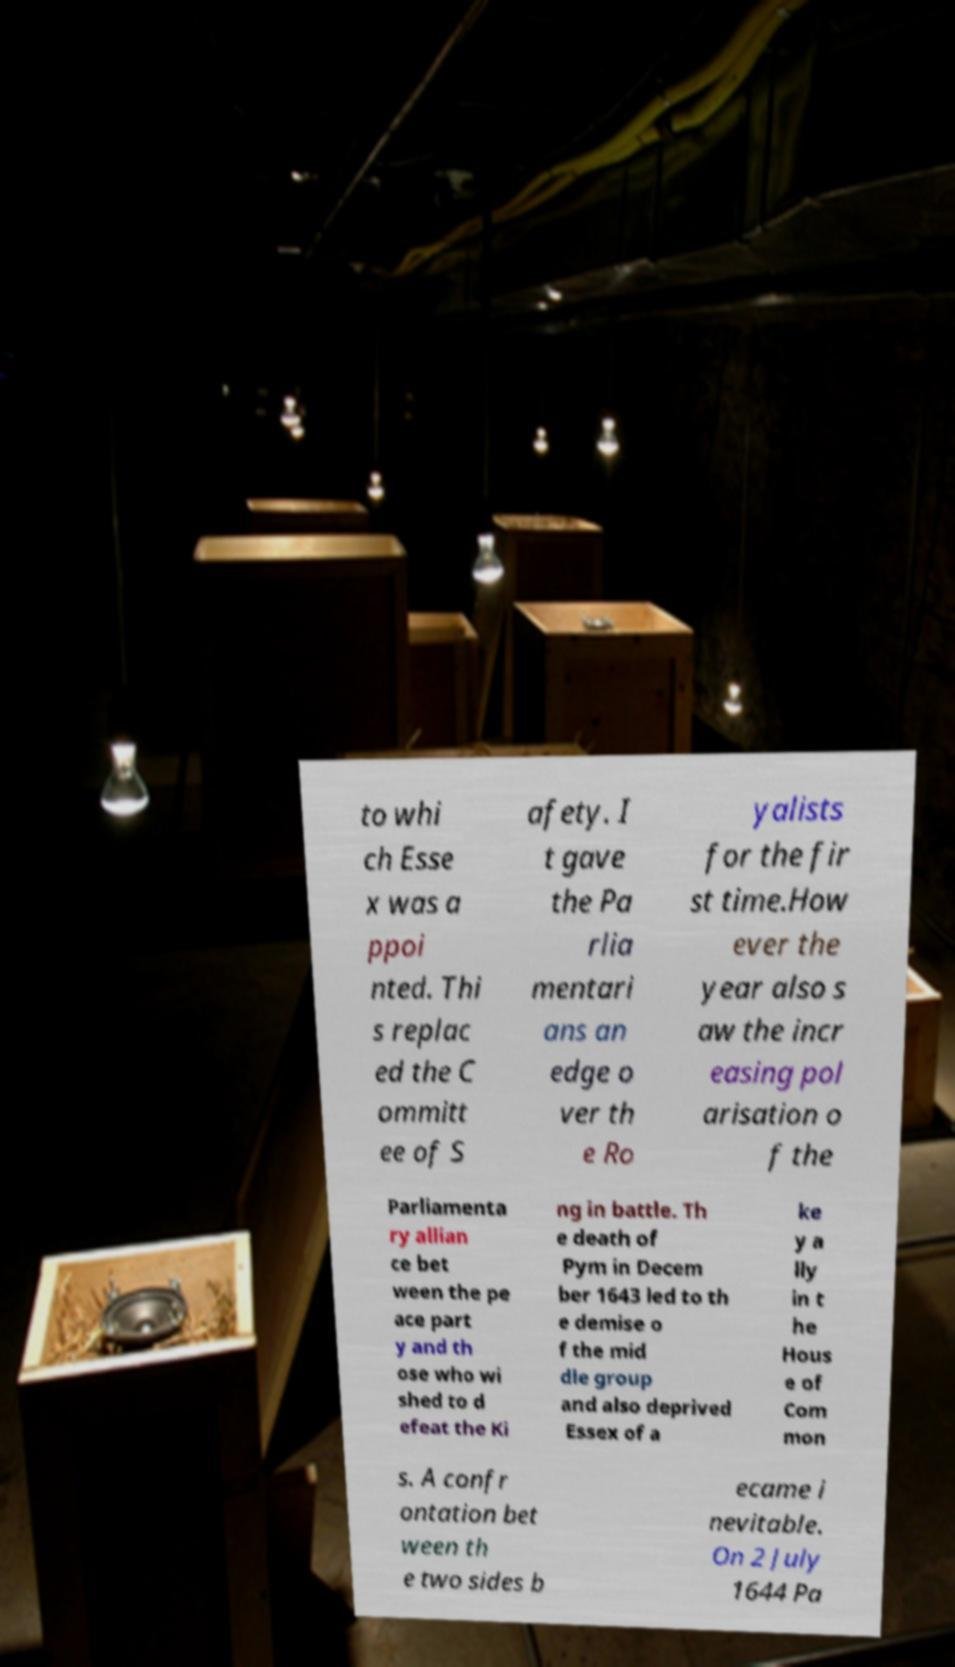Can you accurately transcribe the text from the provided image for me? to whi ch Esse x was a ppoi nted. Thi s replac ed the C ommitt ee of S afety. I t gave the Pa rlia mentari ans an edge o ver th e Ro yalists for the fir st time.How ever the year also s aw the incr easing pol arisation o f the Parliamenta ry allian ce bet ween the pe ace part y and th ose who wi shed to d efeat the Ki ng in battle. Th e death of Pym in Decem ber 1643 led to th e demise o f the mid dle group and also deprived Essex of a ke y a lly in t he Hous e of Com mon s. A confr ontation bet ween th e two sides b ecame i nevitable. On 2 July 1644 Pa 